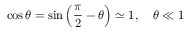Convert formula to latex. <formula><loc_0><loc_0><loc_500><loc_500>\cos \theta = \sin \left ( { \frac { \pi } { 2 } } - \theta \right ) \simeq 1 , \quad \theta \ll 1</formula> 